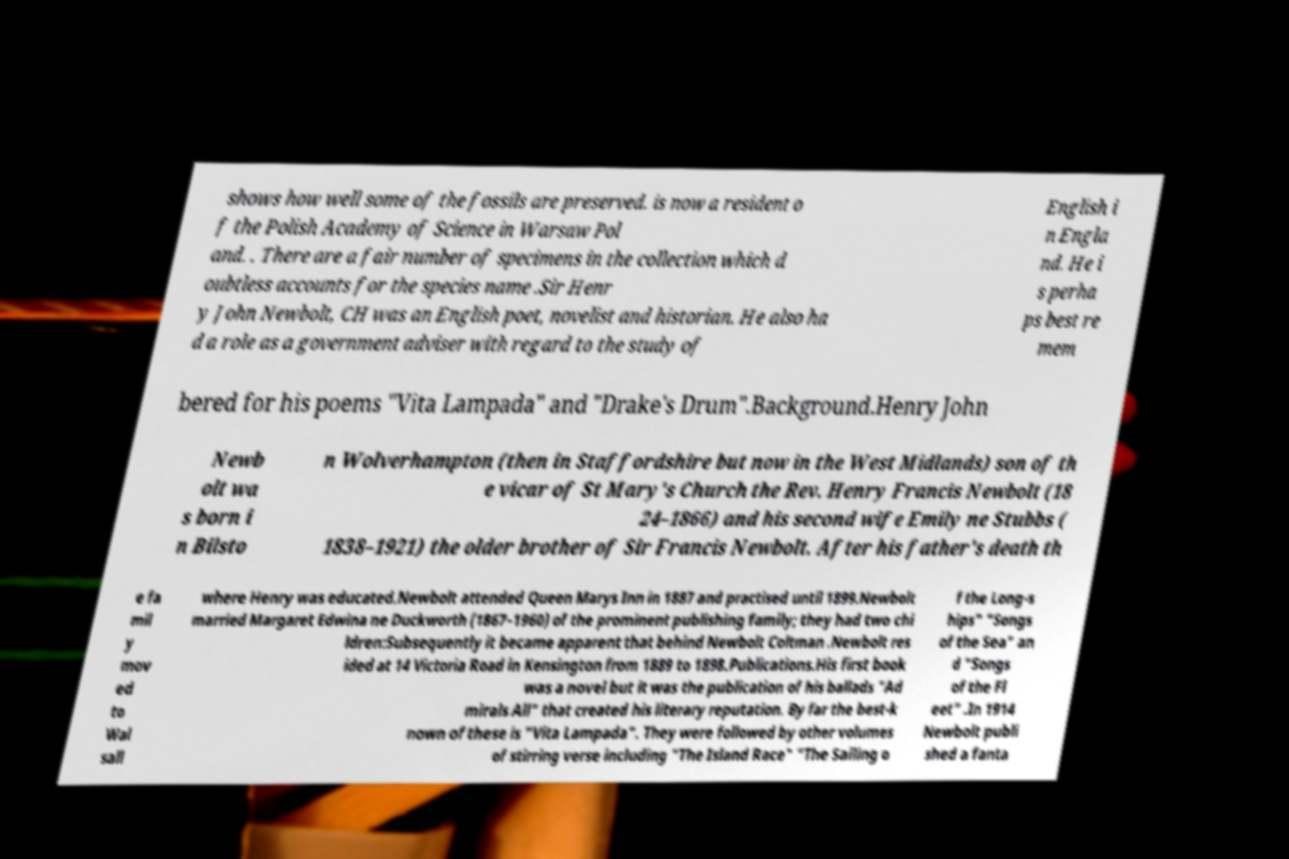Please read and relay the text visible in this image. What does it say? shows how well some of the fossils are preserved. is now a resident o f the Polish Academy of Science in Warsaw Pol and. . There are a fair number of specimens in the collection which d oubtless accounts for the species name .Sir Henr y John Newbolt, CH was an English poet, novelist and historian. He also ha d a role as a government adviser with regard to the study of English i n Engla nd. He i s perha ps best re mem bered for his poems "Vita Lampada" and "Drake's Drum".Background.Henry John Newb olt wa s born i n Bilsto n Wolverhampton (then in Staffordshire but now in the West Midlands) son of th e vicar of St Mary's Church the Rev. Henry Francis Newbolt (18 24–1866) and his second wife Emily ne Stubbs ( 1838–1921) the older brother of Sir Francis Newbolt. After his father's death th e fa mil y mov ed to Wal sall where Henry was educated.Newbolt attended Queen Marys Inn in 1887 and practised until 1899.Newbolt married Margaret Edwina ne Duckworth (1867–1960) of the prominent publishing family; they had two chi ldren:Subsequently it became apparent that behind Newbolt Coltman .Newbolt res ided at 14 Victoria Road in Kensington from 1889 to 1898.Publications.His first book was a novel but it was the publication of his ballads "Ad mirals All" that created his literary reputation. By far the best-k nown of these is "Vita Lampada". They were followed by other volumes of stirring verse including "The Island Race" "The Sailing o f the Long-s hips" "Songs of the Sea" an d "Songs of the Fl eet" .In 1914 Newbolt publi shed a fanta 